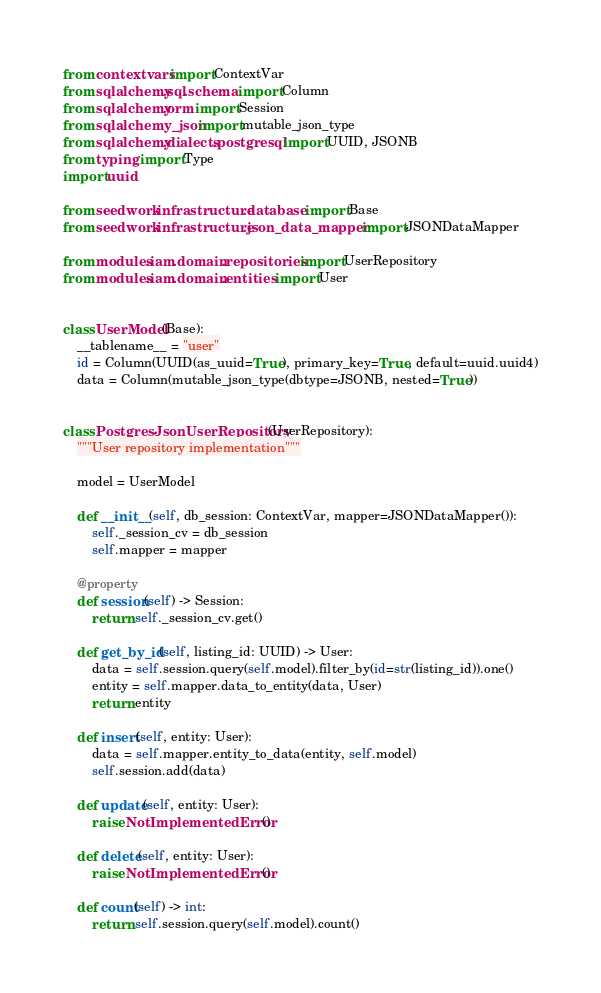<code> <loc_0><loc_0><loc_500><loc_500><_Python_>from contextvars import ContextVar
from sqlalchemy.sql.schema import Column
from sqlalchemy.orm import Session
from sqlalchemy_json import mutable_json_type
from sqlalchemy.dialects.postgresql import UUID, JSONB
from typing import Type
import uuid

from seedwork.infrastructure.database import Base
from seedwork.infrastructure.json_data_mapper import JSONDataMapper

from modules.iam.domain.repositories import UserRepository
from modules.iam.domain.entities import User


class UserModel(Base):
    __tablename__ = "user"
    id = Column(UUID(as_uuid=True), primary_key=True, default=uuid.uuid4)
    data = Column(mutable_json_type(dbtype=JSONB, nested=True))


class PostgresJsonUserRepository(UserRepository):
    """User repository implementation"""

    model = UserModel

    def __init__(self, db_session: ContextVar, mapper=JSONDataMapper()):
        self._session_cv = db_session
        self.mapper = mapper

    @property
    def session(self) -> Session:
        return self._session_cv.get()

    def get_by_id(self, listing_id: UUID) -> User:
        data = self.session.query(self.model).filter_by(id=str(listing_id)).one()
        entity = self.mapper.data_to_entity(data, User)
        return entity

    def insert(self, entity: User):
        data = self.mapper.entity_to_data(entity, self.model)
        self.session.add(data)

    def update(self, entity: User):
        raise NotImplementedError()

    def delete(self, entity: User):
        raise NotImplementedError()

    def count(self) -> int:
        return self.session.query(self.model).count()
</code> 